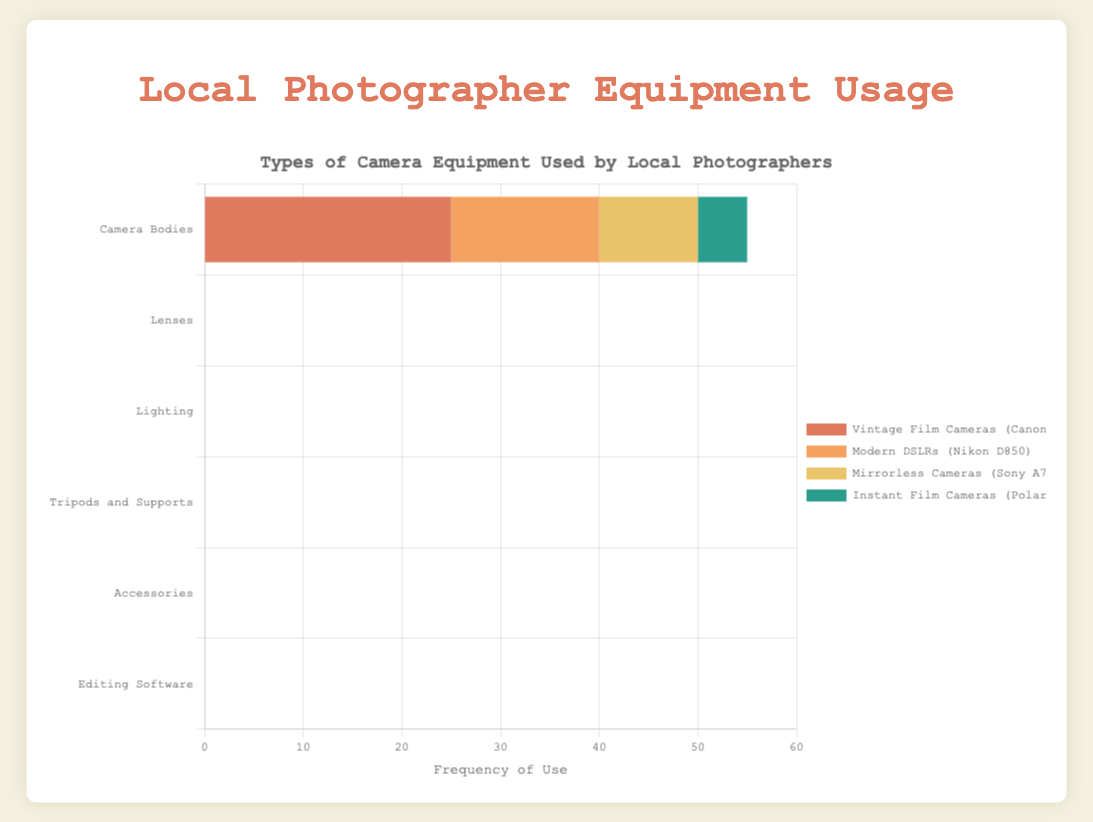What is the most frequently used type of lighting? Look at the bar lengths for the "Lighting" category and compare them. The longest bar corresponds to "Natural Light."
Answer: Natural Light Which category has the highest overall frequency of use? Sum up the frequencies of each subcategory for all categories and compare them. "Editing Software" has the highest overall frequency: Adobe Lightroom (30) + Adobe Photoshop (25) + Capture One (10) + DxO PhotoLab (5) = 70.
Answer: Editing Software Among "Camera Bodies," which type is the least frequently used? Examine the bar lengths for the "Camera Bodies" category and identify the shortest one. The shortest bar corresponds to "Instant Film Cameras (Polaroid OneStep+)."
Answer: Instant Film Cameras (Polaroid OneStep+) In the "Tripods and Supports" category, is the frequency of use of "Standard Tripods (Manfrotto)" greater than the combined frequency of "GorillaPods (Joby)" and "Gimbals (DJI Ronin-S)"? Add the frequencies of "GorillaPods (Joby)" and "Gimbals (DJI Ronin-S)" (10 + 5 = 15) and compare it to "Standard Tripods (Manfrotto)" (25). 25 is greater than 15.
Answer: Yes Compare the use of "Remote Shutter Releases" and "Standard Tripods (Manfrotto)." Which one is more frequently used? Compare the bar lengths of "Remote Shutter Releases" in the "Accessories" category and "Standard Tripods (Manfrotto)" in the "Tripods and Supports" category. "Standard Tripods (Manfrotto)" (25) is more frequently used than "Remote Shutter Releases" (15).
Answer: Standard Tripods (Manfrotto) Which specific item across all categories has a frequency of exactly 15? Check each category for items with a bar length equivalent to a frequency of 15. "Modern DSLRs (Nikon D850)," "Wide-Angle Lenses (Nikon 24mm f/2.8)," "Speedlights," and "Remote Shutter Releases" all have a frequency of 15.
Answer: Modern DSLRs (Nikon D850), Wide-Angle Lenses (Nikon 24mm f/2.8), Speedlights, Remote Shutter Releases How many items have a frequency greater than or equal to 25? Count the items whose bars extend to a frequency of 25 or more across all categories. They are "Adobe Lightroom" (30), "Adobe Photoshop" (25), "Natural Light" (30), "Standard Tripods (Manfrotto)" (25), and "Vintage Film Cameras (Canon AE-1)" (25). There are 5 items in total.
Answer: 5 For "Lenses," is the combined frequency of "50mm Prime Lenses (Canon 50mm f/1.8)" and "Telephoto Lenses (Sigma 70-200mm f/2.8)" greater than "Wide-Angle Lenses (Nikon 24mm f/2.8)"? Add the frequencies of "50mm Prime Lenses (20)" and "Telephoto Lenses (10)" which sums to 30, and compare it to "Wide-Angle Lenses (15)." Since 30 is greater than 15, the combined frequency is indeed greater.
Answer: Yes 